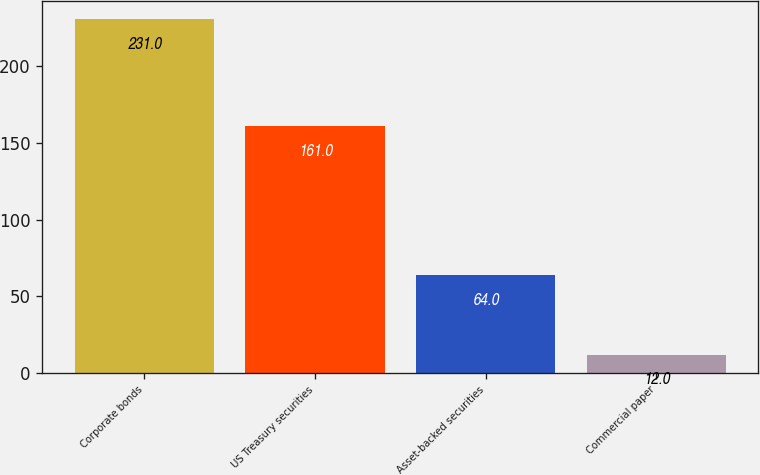Convert chart to OTSL. <chart><loc_0><loc_0><loc_500><loc_500><bar_chart><fcel>Corporate bonds<fcel>US Treasury securities<fcel>Asset-backed securities<fcel>Commercial paper<nl><fcel>231<fcel>161<fcel>64<fcel>12<nl></chart> 